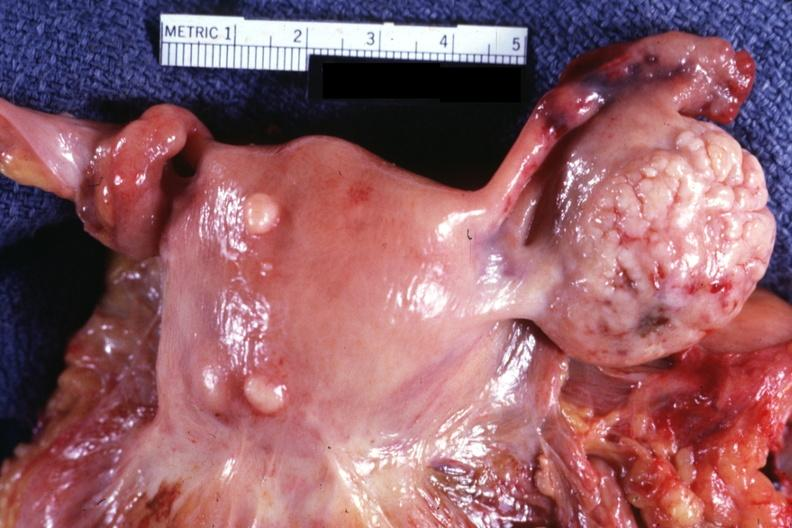what is present?
Answer the question using a single word or phrase. Leiomyoma 